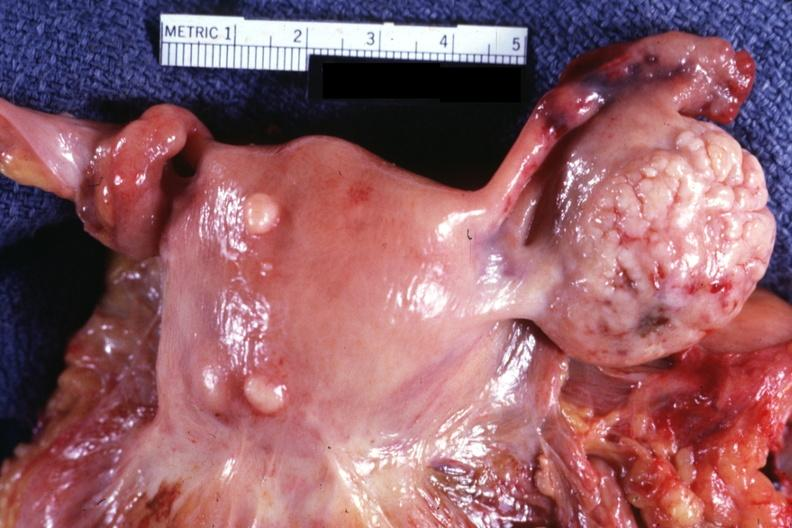what is present?
Answer the question using a single word or phrase. Leiomyoma 